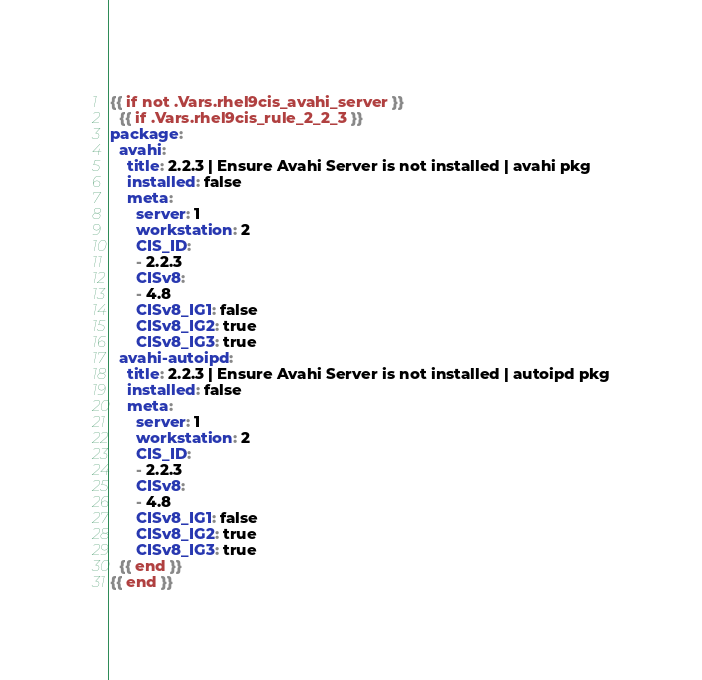Convert code to text. <code><loc_0><loc_0><loc_500><loc_500><_YAML_>{{ if not .Vars.rhel9cis_avahi_server }}
  {{ if .Vars.rhel9cis_rule_2_2_3 }}
package:
  avahi:
    title: 2.2.3 | Ensure Avahi Server is not installed | avahi pkg
    installed: false
    meta:
      server: 1
      workstation: 2
      CIS_ID: 
      - 2.2.3
      CISv8:
      - 4.8
      CISv8_IG1: false
      CISv8_IG2: true
      CISv8_IG3: true
  avahi-autoipd:
    title: 2.2.3 | Ensure Avahi Server is not installed | autoipd pkg
    installed: false
    meta:
      server: 1
      workstation: 2
      CIS_ID: 
      - 2.2.3
      CISv8:
      - 4.8
      CISv8_IG1: false
      CISv8_IG2: true
      CISv8_IG3: true
  {{ end }}
{{ end }}
</code> 